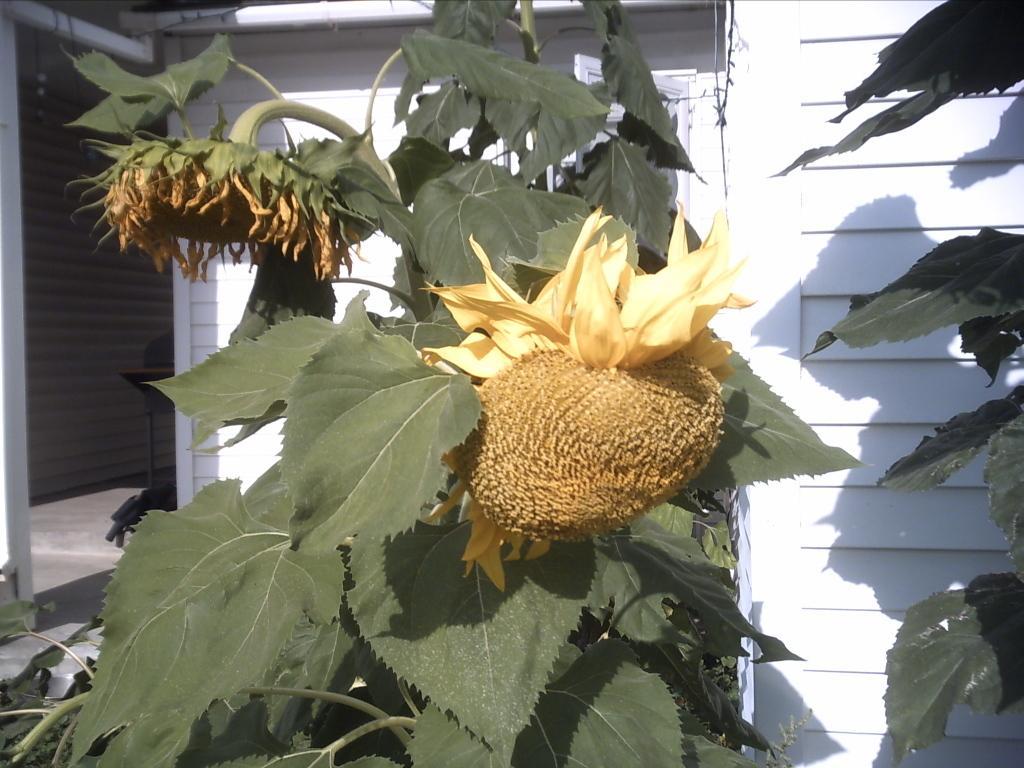Can you describe this image briefly? In this picture I can see flowers and plants, in the background it looks like a wooden house. 